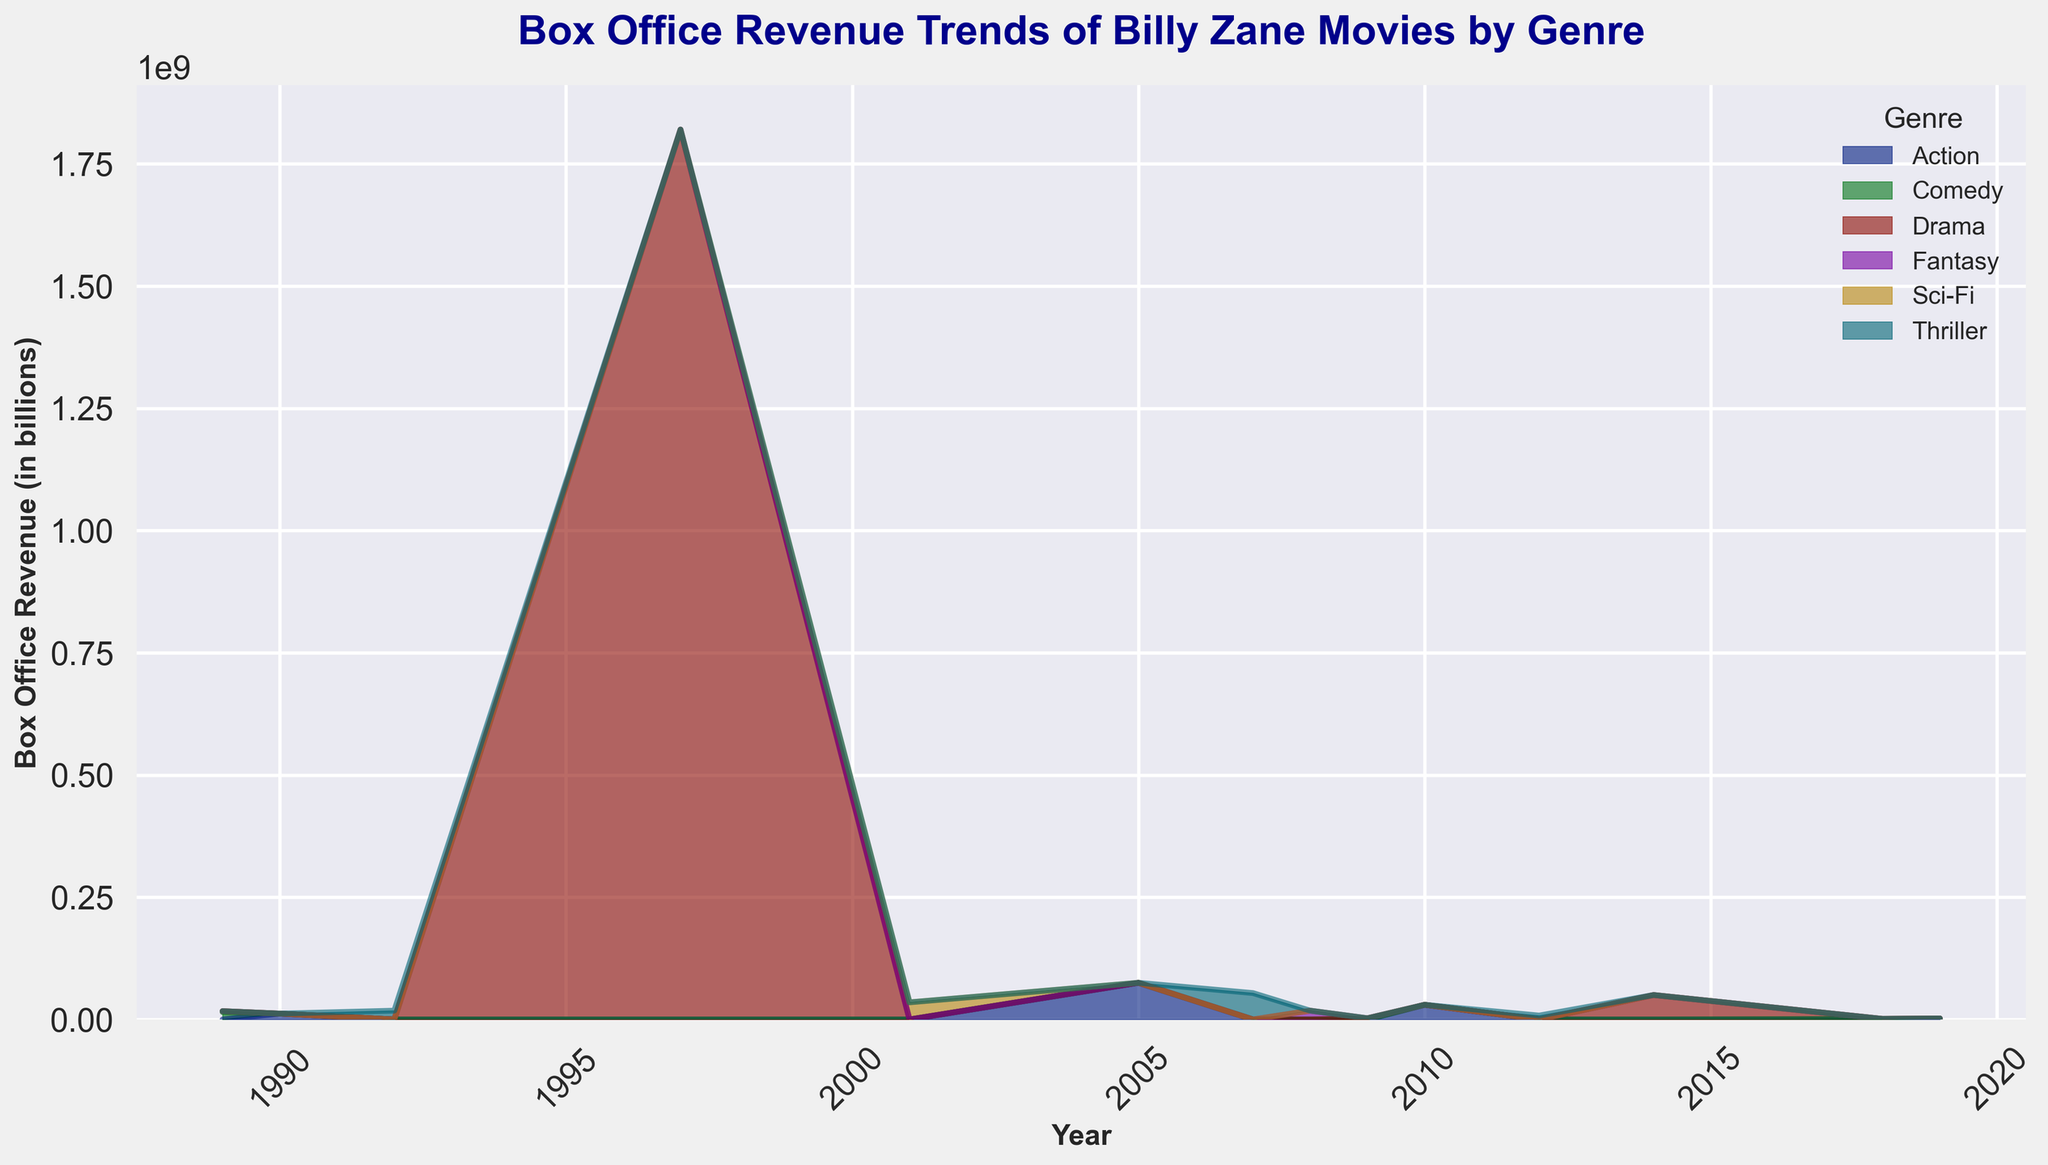What is the total box office revenue for Drama movies? To determine the total box office revenue for Drama movies, you need to add the revenue from all years where the Drama genre was present. Examining the data: 1989 (2000000), 1997 (1820000000), 2009 (2450000), and 2014 (50000000). Thus, the total is 2000000 + 1820000000 + 2450000 + 50000000 = 1872450000
Answer: 1872450000 In which year did Billy Zane's movies generate the highest box office revenue? Look at the peak of the combined area in the area chart to find the year with the highest box office revenue. From the data, it's clear that 1997 stands out, primarily due to the Drama genre.
Answer: 1997 Which genre had the highest box office revenue in 1997? Looking at the area chart for the year 1997, the highest contributing segment would be the largest area corresponding to that year. Observing the data, Drama had a revenue of 1820000000, which is significantly higher than other genres in that year.
Answer: Drama How did the box office revenue for Action movies change from 1990 to 2005? To find this, we compare the height of the areas for Action movies in 1990 and 2005. For 1990 the revenue is 12000000, and for 2005 it is 75000000. Thus, there was an increase of 75000000 - 12000000 = 63000000
Answer: Increased by 63000000 What’s the combined box office revenue for all genres in 1992 and 2007? Sum the areas of all genres for the years 1992 and 2007. For 1992, Thriller = 18000000. For 2007, Thriller = 54000000. Therefore: 18000000 + 54000000 = 72000000
Answer: 72000000 Which genre had the lowest box office revenue in 2012? Look at the smallest segment of the area chart for the year 2012. The data indicates that only the Thriller genre has revenue, which is 8000000.
Answer: Thriller Compare the box office revenue for Comedy movies between 1989 and 2018. To compare, look at the area chart or data for Comedy in both years. In 1989, Comedy revenue is 15000000. In 2018, it is 1200000. Thus, there is a decrease of 15000000 - 1200000 = 13800000
Answer: Decreased by 13800000 What is the combined box office revenue for Thriller movies from 1992 to 2012? Sum the revenue for Thriller for each year it is present: 1992 (18000000), 2007 (54000000), 2012 (8000000). Therefore: 18000000 + 54000000 + 8000000 = 80000000
Answer: 80000000 What is the difference in box office revenue between the highest-grossing genre and the lowest-grossing genre in 2010? In 2010, the only genre is Action, with a revenue of 30000000. So the difference between highest and lowest is 30000000 - 30000000 = 0.
Answer: 0 